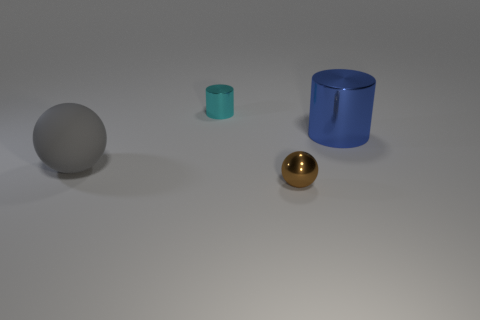Is there any other thing that has the same material as the tiny sphere?
Give a very brief answer. Yes. Is the number of large gray matte balls that are behind the big metal cylinder greater than the number of brown metallic spheres?
Provide a succinct answer. No. How many small cylinders are in front of the sphere to the left of the small object behind the big gray ball?
Offer a very short reply. 0. There is a ball that is behind the tiny shiny sphere; is its size the same as the cylinder that is in front of the tiny cyan metal cylinder?
Your answer should be compact. Yes. The ball right of the cylinder left of the brown shiny ball is made of what material?
Your response must be concise. Metal. What number of things are small objects in front of the small cyan metal object or big rubber objects?
Keep it short and to the point. 2. Are there the same number of large rubber balls that are behind the big matte ball and spheres that are behind the cyan shiny cylinder?
Provide a succinct answer. Yes. There is a thing that is behind the big object to the right of the big ball that is left of the blue metallic cylinder; what is it made of?
Provide a succinct answer. Metal. How big is the metal object that is both to the left of the large blue cylinder and behind the brown metal ball?
Your answer should be compact. Small. Do the big blue thing and the cyan metal thing have the same shape?
Offer a terse response. Yes. 